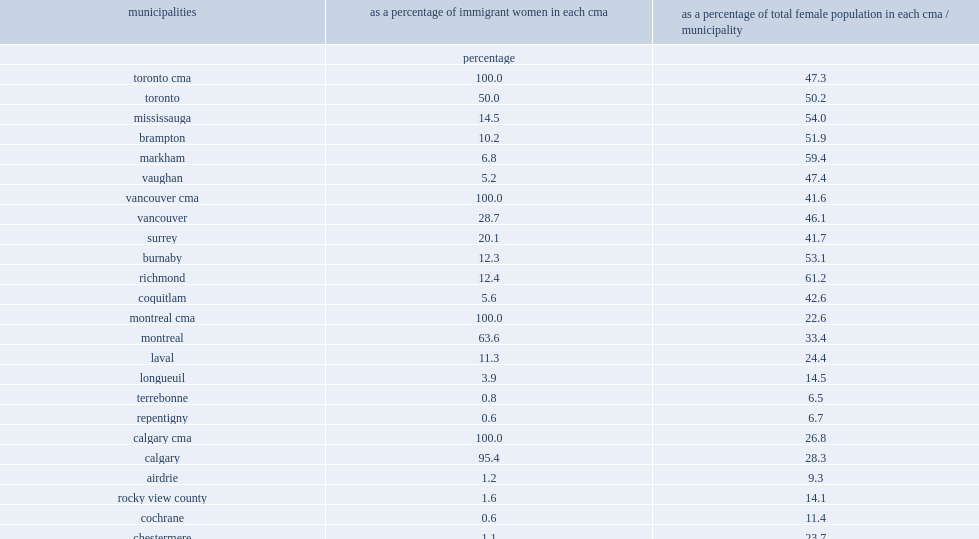Would you be able to parse every entry in this table? {'header': ['municipalities', 'as a percentage of immigrant women in each cma', 'as a percentage of total female population in each cma / municipality'], 'rows': [['', 'percentage', ''], ['toronto cma', '100.0', '47.3'], ['toronto', '50.0', '50.2'], ['mississauga', '14.5', '54.0'], ['brampton', '10.2', '51.9'], ['markham', '6.8', '59.4'], ['vaughan', '5.2', '47.4'], ['vancouver cma', '100.0', '41.6'], ['vancouver', '28.7', '46.1'], ['surrey', '20.1', '41.7'], ['burnaby', '12.3', '53.1'], ['richmond', '12.4', '61.2'], ['coquitlam', '5.6', '42.6'], ['montreal cma', '100.0', '22.6'], ['montreal', '63.6', '33.4'], ['laval', '11.3', '24.4'], ['longueuil', '3.9', '14.5'], ['terrebonne', '0.8', '6.5'], ['repentigny', '0.6', '6.7'], ['calgary cma', '100.0', '26.8'], ['calgary', '95.4', '28.3'], ['airdrie', '1.2', '9.3'], ['rocky view county', '1.6', '14.1'], ['cochrane', '0.6', '11.4'], ['chestermere', '1.1', '23.7']]} What the percentage point of the municipality of markham was home to female immigrants living in the cma of toronto in 2011? 6.8. What the percentage point of all females were immigrants within municipality of markham in 2011? 59.4. What the percentage point of female immigrants was home to richmond in the vancouver cma in 2011? 12.4. What the percentage point of female residents did immigrant women and girls make up in the vancouver cma in 2011? 61.2. 